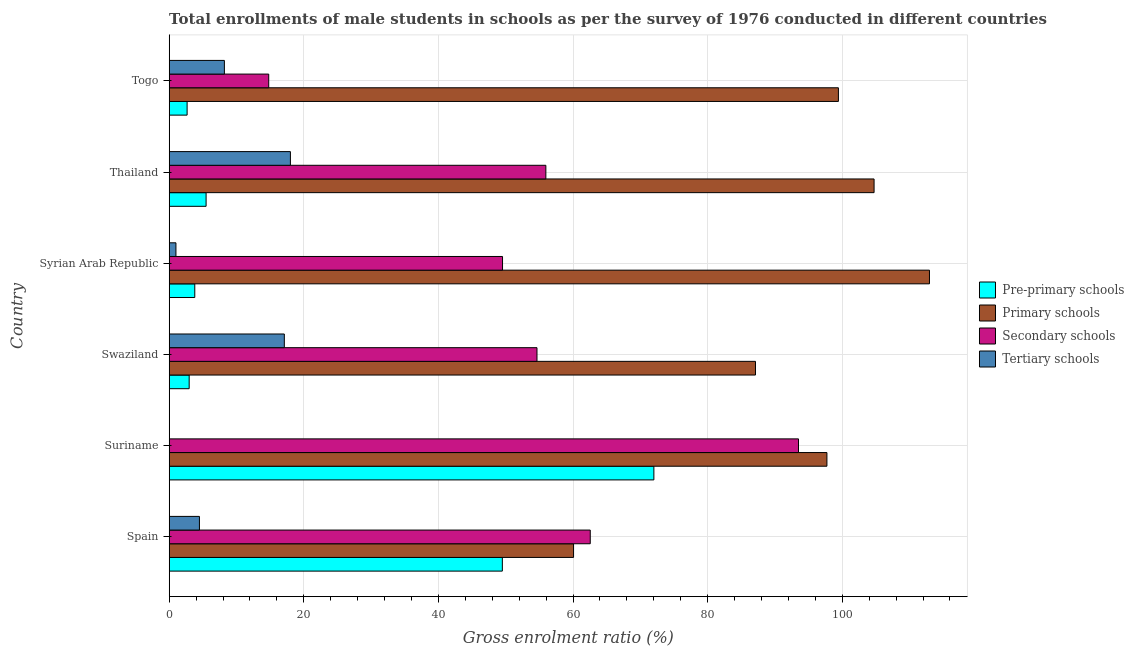How many different coloured bars are there?
Offer a very short reply. 4. How many groups of bars are there?
Your response must be concise. 6. Are the number of bars per tick equal to the number of legend labels?
Provide a succinct answer. Yes. How many bars are there on the 6th tick from the top?
Keep it short and to the point. 4. What is the label of the 1st group of bars from the top?
Keep it short and to the point. Togo. What is the gross enrolment ratio(male) in secondary schools in Swaziland?
Offer a terse response. 54.64. Across all countries, what is the maximum gross enrolment ratio(male) in pre-primary schools?
Ensure brevity in your answer.  72.01. Across all countries, what is the minimum gross enrolment ratio(male) in secondary schools?
Offer a terse response. 14.79. In which country was the gross enrolment ratio(male) in tertiary schools maximum?
Provide a succinct answer. Thailand. In which country was the gross enrolment ratio(male) in pre-primary schools minimum?
Give a very brief answer. Togo. What is the total gross enrolment ratio(male) in pre-primary schools in the graph?
Provide a succinct answer. 136.42. What is the difference between the gross enrolment ratio(male) in pre-primary schools in Suriname and that in Thailand?
Your response must be concise. 66.53. What is the difference between the gross enrolment ratio(male) in pre-primary schools in Suriname and the gross enrolment ratio(male) in secondary schools in Thailand?
Ensure brevity in your answer.  16.05. What is the average gross enrolment ratio(male) in tertiary schools per country?
Keep it short and to the point. 8.14. What is the difference between the gross enrolment ratio(male) in pre-primary schools and gross enrolment ratio(male) in tertiary schools in Syrian Arab Republic?
Ensure brevity in your answer.  2.8. In how many countries, is the gross enrolment ratio(male) in secondary schools greater than 48 %?
Provide a short and direct response. 5. What is the ratio of the gross enrolment ratio(male) in pre-primary schools in Spain to that in Swaziland?
Your response must be concise. 16.69. Is the gross enrolment ratio(male) in tertiary schools in Swaziland less than that in Togo?
Your answer should be very brief. No. What is the difference between the highest and the second highest gross enrolment ratio(male) in pre-primary schools?
Your response must be concise. 22.51. What is the difference between the highest and the lowest gross enrolment ratio(male) in pre-primary schools?
Your answer should be very brief. 69.35. Is the sum of the gross enrolment ratio(male) in tertiary schools in Suriname and Syrian Arab Republic greater than the maximum gross enrolment ratio(male) in secondary schools across all countries?
Make the answer very short. No. Is it the case that in every country, the sum of the gross enrolment ratio(male) in pre-primary schools and gross enrolment ratio(male) in primary schools is greater than the sum of gross enrolment ratio(male) in tertiary schools and gross enrolment ratio(male) in secondary schools?
Your answer should be very brief. Yes. What does the 3rd bar from the top in Swaziland represents?
Your answer should be very brief. Primary schools. What does the 4th bar from the bottom in Togo represents?
Make the answer very short. Tertiary schools. Is it the case that in every country, the sum of the gross enrolment ratio(male) in pre-primary schools and gross enrolment ratio(male) in primary schools is greater than the gross enrolment ratio(male) in secondary schools?
Make the answer very short. Yes. How many countries are there in the graph?
Provide a succinct answer. 6. What is the difference between two consecutive major ticks on the X-axis?
Give a very brief answer. 20. Where does the legend appear in the graph?
Your answer should be compact. Center right. How many legend labels are there?
Offer a very short reply. 4. How are the legend labels stacked?
Offer a very short reply. Vertical. What is the title of the graph?
Ensure brevity in your answer.  Total enrollments of male students in schools as per the survey of 1976 conducted in different countries. Does "Other greenhouse gases" appear as one of the legend labels in the graph?
Keep it short and to the point. No. What is the Gross enrolment ratio (%) of Pre-primary schools in Spain?
Offer a very short reply. 49.5. What is the Gross enrolment ratio (%) in Primary schools in Spain?
Keep it short and to the point. 60.08. What is the Gross enrolment ratio (%) in Secondary schools in Spain?
Your response must be concise. 62.56. What is the Gross enrolment ratio (%) in Tertiary schools in Spain?
Provide a succinct answer. 4.49. What is the Gross enrolment ratio (%) in Pre-primary schools in Suriname?
Offer a very short reply. 72.01. What is the Gross enrolment ratio (%) in Primary schools in Suriname?
Give a very brief answer. 97.72. What is the Gross enrolment ratio (%) of Secondary schools in Suriname?
Keep it short and to the point. 93.5. What is the Gross enrolment ratio (%) in Tertiary schools in Suriname?
Give a very brief answer. 0.03. What is the Gross enrolment ratio (%) of Pre-primary schools in Swaziland?
Your answer should be compact. 2.97. What is the Gross enrolment ratio (%) in Primary schools in Swaziland?
Ensure brevity in your answer.  87.11. What is the Gross enrolment ratio (%) of Secondary schools in Swaziland?
Ensure brevity in your answer.  54.64. What is the Gross enrolment ratio (%) in Tertiary schools in Swaziland?
Provide a short and direct response. 17.1. What is the Gross enrolment ratio (%) of Pre-primary schools in Syrian Arab Republic?
Your answer should be compact. 3.8. What is the Gross enrolment ratio (%) of Primary schools in Syrian Arab Republic?
Give a very brief answer. 112.96. What is the Gross enrolment ratio (%) of Secondary schools in Syrian Arab Republic?
Make the answer very short. 49.53. What is the Gross enrolment ratio (%) of Tertiary schools in Syrian Arab Republic?
Offer a very short reply. 1. What is the Gross enrolment ratio (%) of Pre-primary schools in Thailand?
Ensure brevity in your answer.  5.48. What is the Gross enrolment ratio (%) of Primary schools in Thailand?
Ensure brevity in your answer.  104.73. What is the Gross enrolment ratio (%) of Secondary schools in Thailand?
Offer a terse response. 55.96. What is the Gross enrolment ratio (%) in Tertiary schools in Thailand?
Offer a terse response. 18.01. What is the Gross enrolment ratio (%) of Pre-primary schools in Togo?
Make the answer very short. 2.66. What is the Gross enrolment ratio (%) in Primary schools in Togo?
Provide a short and direct response. 99.43. What is the Gross enrolment ratio (%) of Secondary schools in Togo?
Provide a short and direct response. 14.79. What is the Gross enrolment ratio (%) of Tertiary schools in Togo?
Your response must be concise. 8.2. Across all countries, what is the maximum Gross enrolment ratio (%) in Pre-primary schools?
Make the answer very short. 72.01. Across all countries, what is the maximum Gross enrolment ratio (%) of Primary schools?
Ensure brevity in your answer.  112.96. Across all countries, what is the maximum Gross enrolment ratio (%) in Secondary schools?
Provide a succinct answer. 93.5. Across all countries, what is the maximum Gross enrolment ratio (%) in Tertiary schools?
Your answer should be compact. 18.01. Across all countries, what is the minimum Gross enrolment ratio (%) of Pre-primary schools?
Keep it short and to the point. 2.66. Across all countries, what is the minimum Gross enrolment ratio (%) of Primary schools?
Offer a terse response. 60.08. Across all countries, what is the minimum Gross enrolment ratio (%) in Secondary schools?
Keep it short and to the point. 14.79. Across all countries, what is the minimum Gross enrolment ratio (%) of Tertiary schools?
Your answer should be very brief. 0.03. What is the total Gross enrolment ratio (%) in Pre-primary schools in the graph?
Offer a very short reply. 136.42. What is the total Gross enrolment ratio (%) in Primary schools in the graph?
Offer a very short reply. 562.03. What is the total Gross enrolment ratio (%) of Secondary schools in the graph?
Give a very brief answer. 330.98. What is the total Gross enrolment ratio (%) in Tertiary schools in the graph?
Keep it short and to the point. 48.83. What is the difference between the Gross enrolment ratio (%) in Pre-primary schools in Spain and that in Suriname?
Your response must be concise. -22.51. What is the difference between the Gross enrolment ratio (%) of Primary schools in Spain and that in Suriname?
Offer a terse response. -37.64. What is the difference between the Gross enrolment ratio (%) of Secondary schools in Spain and that in Suriname?
Provide a short and direct response. -30.94. What is the difference between the Gross enrolment ratio (%) of Tertiary schools in Spain and that in Suriname?
Ensure brevity in your answer.  4.47. What is the difference between the Gross enrolment ratio (%) of Pre-primary schools in Spain and that in Swaziland?
Your response must be concise. 46.53. What is the difference between the Gross enrolment ratio (%) in Primary schools in Spain and that in Swaziland?
Offer a terse response. -27.03. What is the difference between the Gross enrolment ratio (%) of Secondary schools in Spain and that in Swaziland?
Keep it short and to the point. 7.92. What is the difference between the Gross enrolment ratio (%) in Tertiary schools in Spain and that in Swaziland?
Provide a succinct answer. -12.61. What is the difference between the Gross enrolment ratio (%) of Pre-primary schools in Spain and that in Syrian Arab Republic?
Keep it short and to the point. 45.7. What is the difference between the Gross enrolment ratio (%) of Primary schools in Spain and that in Syrian Arab Republic?
Provide a short and direct response. -52.88. What is the difference between the Gross enrolment ratio (%) in Secondary schools in Spain and that in Syrian Arab Republic?
Keep it short and to the point. 13.03. What is the difference between the Gross enrolment ratio (%) in Tertiary schools in Spain and that in Syrian Arab Republic?
Make the answer very short. 3.49. What is the difference between the Gross enrolment ratio (%) of Pre-primary schools in Spain and that in Thailand?
Your answer should be compact. 44.02. What is the difference between the Gross enrolment ratio (%) of Primary schools in Spain and that in Thailand?
Provide a short and direct response. -44.65. What is the difference between the Gross enrolment ratio (%) in Secondary schools in Spain and that in Thailand?
Ensure brevity in your answer.  6.6. What is the difference between the Gross enrolment ratio (%) in Tertiary schools in Spain and that in Thailand?
Give a very brief answer. -13.52. What is the difference between the Gross enrolment ratio (%) in Pre-primary schools in Spain and that in Togo?
Your answer should be very brief. 46.84. What is the difference between the Gross enrolment ratio (%) in Primary schools in Spain and that in Togo?
Make the answer very short. -39.35. What is the difference between the Gross enrolment ratio (%) of Secondary schools in Spain and that in Togo?
Provide a succinct answer. 47.77. What is the difference between the Gross enrolment ratio (%) in Tertiary schools in Spain and that in Togo?
Your response must be concise. -3.71. What is the difference between the Gross enrolment ratio (%) of Pre-primary schools in Suriname and that in Swaziland?
Offer a very short reply. 69.04. What is the difference between the Gross enrolment ratio (%) in Primary schools in Suriname and that in Swaziland?
Offer a very short reply. 10.62. What is the difference between the Gross enrolment ratio (%) in Secondary schools in Suriname and that in Swaziland?
Make the answer very short. 38.86. What is the difference between the Gross enrolment ratio (%) of Tertiary schools in Suriname and that in Swaziland?
Your answer should be very brief. -17.08. What is the difference between the Gross enrolment ratio (%) in Pre-primary schools in Suriname and that in Syrian Arab Republic?
Your response must be concise. 68.21. What is the difference between the Gross enrolment ratio (%) of Primary schools in Suriname and that in Syrian Arab Republic?
Give a very brief answer. -15.23. What is the difference between the Gross enrolment ratio (%) of Secondary schools in Suriname and that in Syrian Arab Republic?
Offer a very short reply. 43.97. What is the difference between the Gross enrolment ratio (%) in Tertiary schools in Suriname and that in Syrian Arab Republic?
Ensure brevity in your answer.  -0.97. What is the difference between the Gross enrolment ratio (%) of Pre-primary schools in Suriname and that in Thailand?
Offer a terse response. 66.53. What is the difference between the Gross enrolment ratio (%) in Primary schools in Suriname and that in Thailand?
Offer a very short reply. -7.01. What is the difference between the Gross enrolment ratio (%) of Secondary schools in Suriname and that in Thailand?
Give a very brief answer. 37.54. What is the difference between the Gross enrolment ratio (%) of Tertiary schools in Suriname and that in Thailand?
Ensure brevity in your answer.  -17.98. What is the difference between the Gross enrolment ratio (%) in Pre-primary schools in Suriname and that in Togo?
Offer a very short reply. 69.35. What is the difference between the Gross enrolment ratio (%) of Primary schools in Suriname and that in Togo?
Your answer should be compact. -1.71. What is the difference between the Gross enrolment ratio (%) in Secondary schools in Suriname and that in Togo?
Your answer should be very brief. 78.71. What is the difference between the Gross enrolment ratio (%) of Tertiary schools in Suriname and that in Togo?
Keep it short and to the point. -8.17. What is the difference between the Gross enrolment ratio (%) of Pre-primary schools in Swaziland and that in Syrian Arab Republic?
Keep it short and to the point. -0.83. What is the difference between the Gross enrolment ratio (%) of Primary schools in Swaziland and that in Syrian Arab Republic?
Your response must be concise. -25.85. What is the difference between the Gross enrolment ratio (%) in Secondary schools in Swaziland and that in Syrian Arab Republic?
Offer a terse response. 5.12. What is the difference between the Gross enrolment ratio (%) in Tertiary schools in Swaziland and that in Syrian Arab Republic?
Offer a terse response. 16.1. What is the difference between the Gross enrolment ratio (%) of Pre-primary schools in Swaziland and that in Thailand?
Offer a terse response. -2.51. What is the difference between the Gross enrolment ratio (%) in Primary schools in Swaziland and that in Thailand?
Keep it short and to the point. -17.62. What is the difference between the Gross enrolment ratio (%) of Secondary schools in Swaziland and that in Thailand?
Offer a terse response. -1.32. What is the difference between the Gross enrolment ratio (%) of Tertiary schools in Swaziland and that in Thailand?
Keep it short and to the point. -0.9. What is the difference between the Gross enrolment ratio (%) in Pre-primary schools in Swaziland and that in Togo?
Provide a succinct answer. 0.31. What is the difference between the Gross enrolment ratio (%) in Primary schools in Swaziland and that in Togo?
Keep it short and to the point. -12.32. What is the difference between the Gross enrolment ratio (%) in Secondary schools in Swaziland and that in Togo?
Make the answer very short. 39.86. What is the difference between the Gross enrolment ratio (%) in Tertiary schools in Swaziland and that in Togo?
Ensure brevity in your answer.  8.91. What is the difference between the Gross enrolment ratio (%) of Pre-primary schools in Syrian Arab Republic and that in Thailand?
Give a very brief answer. -1.68. What is the difference between the Gross enrolment ratio (%) of Primary schools in Syrian Arab Republic and that in Thailand?
Provide a short and direct response. 8.23. What is the difference between the Gross enrolment ratio (%) of Secondary schools in Syrian Arab Republic and that in Thailand?
Provide a succinct answer. -6.44. What is the difference between the Gross enrolment ratio (%) in Tertiary schools in Syrian Arab Republic and that in Thailand?
Provide a short and direct response. -17.01. What is the difference between the Gross enrolment ratio (%) in Pre-primary schools in Syrian Arab Republic and that in Togo?
Offer a terse response. 1.14. What is the difference between the Gross enrolment ratio (%) in Primary schools in Syrian Arab Republic and that in Togo?
Your response must be concise. 13.53. What is the difference between the Gross enrolment ratio (%) in Secondary schools in Syrian Arab Republic and that in Togo?
Your answer should be very brief. 34.74. What is the difference between the Gross enrolment ratio (%) of Tertiary schools in Syrian Arab Republic and that in Togo?
Your answer should be very brief. -7.2. What is the difference between the Gross enrolment ratio (%) of Pre-primary schools in Thailand and that in Togo?
Give a very brief answer. 2.82. What is the difference between the Gross enrolment ratio (%) in Primary schools in Thailand and that in Togo?
Ensure brevity in your answer.  5.3. What is the difference between the Gross enrolment ratio (%) in Secondary schools in Thailand and that in Togo?
Your answer should be very brief. 41.18. What is the difference between the Gross enrolment ratio (%) of Tertiary schools in Thailand and that in Togo?
Provide a succinct answer. 9.81. What is the difference between the Gross enrolment ratio (%) of Pre-primary schools in Spain and the Gross enrolment ratio (%) of Primary schools in Suriname?
Ensure brevity in your answer.  -48.23. What is the difference between the Gross enrolment ratio (%) in Pre-primary schools in Spain and the Gross enrolment ratio (%) in Secondary schools in Suriname?
Your answer should be compact. -44. What is the difference between the Gross enrolment ratio (%) of Pre-primary schools in Spain and the Gross enrolment ratio (%) of Tertiary schools in Suriname?
Offer a very short reply. 49.47. What is the difference between the Gross enrolment ratio (%) of Primary schools in Spain and the Gross enrolment ratio (%) of Secondary schools in Suriname?
Provide a short and direct response. -33.42. What is the difference between the Gross enrolment ratio (%) of Primary schools in Spain and the Gross enrolment ratio (%) of Tertiary schools in Suriname?
Your answer should be compact. 60.05. What is the difference between the Gross enrolment ratio (%) of Secondary schools in Spain and the Gross enrolment ratio (%) of Tertiary schools in Suriname?
Keep it short and to the point. 62.53. What is the difference between the Gross enrolment ratio (%) in Pre-primary schools in Spain and the Gross enrolment ratio (%) in Primary schools in Swaziland?
Give a very brief answer. -37.61. What is the difference between the Gross enrolment ratio (%) of Pre-primary schools in Spain and the Gross enrolment ratio (%) of Secondary schools in Swaziland?
Your answer should be very brief. -5.15. What is the difference between the Gross enrolment ratio (%) of Pre-primary schools in Spain and the Gross enrolment ratio (%) of Tertiary schools in Swaziland?
Your response must be concise. 32.39. What is the difference between the Gross enrolment ratio (%) in Primary schools in Spain and the Gross enrolment ratio (%) in Secondary schools in Swaziland?
Offer a terse response. 5.44. What is the difference between the Gross enrolment ratio (%) of Primary schools in Spain and the Gross enrolment ratio (%) of Tertiary schools in Swaziland?
Your response must be concise. 42.97. What is the difference between the Gross enrolment ratio (%) in Secondary schools in Spain and the Gross enrolment ratio (%) in Tertiary schools in Swaziland?
Make the answer very short. 45.45. What is the difference between the Gross enrolment ratio (%) in Pre-primary schools in Spain and the Gross enrolment ratio (%) in Primary schools in Syrian Arab Republic?
Keep it short and to the point. -63.46. What is the difference between the Gross enrolment ratio (%) in Pre-primary schools in Spain and the Gross enrolment ratio (%) in Secondary schools in Syrian Arab Republic?
Make the answer very short. -0.03. What is the difference between the Gross enrolment ratio (%) in Pre-primary schools in Spain and the Gross enrolment ratio (%) in Tertiary schools in Syrian Arab Republic?
Keep it short and to the point. 48.5. What is the difference between the Gross enrolment ratio (%) in Primary schools in Spain and the Gross enrolment ratio (%) in Secondary schools in Syrian Arab Republic?
Your response must be concise. 10.55. What is the difference between the Gross enrolment ratio (%) in Primary schools in Spain and the Gross enrolment ratio (%) in Tertiary schools in Syrian Arab Republic?
Give a very brief answer. 59.08. What is the difference between the Gross enrolment ratio (%) of Secondary schools in Spain and the Gross enrolment ratio (%) of Tertiary schools in Syrian Arab Republic?
Your answer should be compact. 61.56. What is the difference between the Gross enrolment ratio (%) in Pre-primary schools in Spain and the Gross enrolment ratio (%) in Primary schools in Thailand?
Your response must be concise. -55.23. What is the difference between the Gross enrolment ratio (%) in Pre-primary schools in Spain and the Gross enrolment ratio (%) in Secondary schools in Thailand?
Make the answer very short. -6.46. What is the difference between the Gross enrolment ratio (%) of Pre-primary schools in Spain and the Gross enrolment ratio (%) of Tertiary schools in Thailand?
Your response must be concise. 31.49. What is the difference between the Gross enrolment ratio (%) of Primary schools in Spain and the Gross enrolment ratio (%) of Secondary schools in Thailand?
Keep it short and to the point. 4.12. What is the difference between the Gross enrolment ratio (%) of Primary schools in Spain and the Gross enrolment ratio (%) of Tertiary schools in Thailand?
Keep it short and to the point. 42.07. What is the difference between the Gross enrolment ratio (%) of Secondary schools in Spain and the Gross enrolment ratio (%) of Tertiary schools in Thailand?
Give a very brief answer. 44.55. What is the difference between the Gross enrolment ratio (%) of Pre-primary schools in Spain and the Gross enrolment ratio (%) of Primary schools in Togo?
Offer a very short reply. -49.93. What is the difference between the Gross enrolment ratio (%) in Pre-primary schools in Spain and the Gross enrolment ratio (%) in Secondary schools in Togo?
Provide a succinct answer. 34.71. What is the difference between the Gross enrolment ratio (%) in Pre-primary schools in Spain and the Gross enrolment ratio (%) in Tertiary schools in Togo?
Keep it short and to the point. 41.3. What is the difference between the Gross enrolment ratio (%) in Primary schools in Spain and the Gross enrolment ratio (%) in Secondary schools in Togo?
Offer a very short reply. 45.29. What is the difference between the Gross enrolment ratio (%) in Primary schools in Spain and the Gross enrolment ratio (%) in Tertiary schools in Togo?
Give a very brief answer. 51.88. What is the difference between the Gross enrolment ratio (%) of Secondary schools in Spain and the Gross enrolment ratio (%) of Tertiary schools in Togo?
Your response must be concise. 54.36. What is the difference between the Gross enrolment ratio (%) in Pre-primary schools in Suriname and the Gross enrolment ratio (%) in Primary schools in Swaziland?
Provide a short and direct response. -15.1. What is the difference between the Gross enrolment ratio (%) in Pre-primary schools in Suriname and the Gross enrolment ratio (%) in Secondary schools in Swaziland?
Keep it short and to the point. 17.37. What is the difference between the Gross enrolment ratio (%) of Pre-primary schools in Suriname and the Gross enrolment ratio (%) of Tertiary schools in Swaziland?
Give a very brief answer. 54.91. What is the difference between the Gross enrolment ratio (%) in Primary schools in Suriname and the Gross enrolment ratio (%) in Secondary schools in Swaziland?
Provide a succinct answer. 43.08. What is the difference between the Gross enrolment ratio (%) of Primary schools in Suriname and the Gross enrolment ratio (%) of Tertiary schools in Swaziland?
Keep it short and to the point. 80.62. What is the difference between the Gross enrolment ratio (%) of Secondary schools in Suriname and the Gross enrolment ratio (%) of Tertiary schools in Swaziland?
Offer a terse response. 76.39. What is the difference between the Gross enrolment ratio (%) of Pre-primary schools in Suriname and the Gross enrolment ratio (%) of Primary schools in Syrian Arab Republic?
Provide a short and direct response. -40.95. What is the difference between the Gross enrolment ratio (%) of Pre-primary schools in Suriname and the Gross enrolment ratio (%) of Secondary schools in Syrian Arab Republic?
Offer a very short reply. 22.48. What is the difference between the Gross enrolment ratio (%) of Pre-primary schools in Suriname and the Gross enrolment ratio (%) of Tertiary schools in Syrian Arab Republic?
Provide a succinct answer. 71.01. What is the difference between the Gross enrolment ratio (%) of Primary schools in Suriname and the Gross enrolment ratio (%) of Secondary schools in Syrian Arab Republic?
Provide a succinct answer. 48.2. What is the difference between the Gross enrolment ratio (%) of Primary schools in Suriname and the Gross enrolment ratio (%) of Tertiary schools in Syrian Arab Republic?
Provide a succinct answer. 96.72. What is the difference between the Gross enrolment ratio (%) of Secondary schools in Suriname and the Gross enrolment ratio (%) of Tertiary schools in Syrian Arab Republic?
Offer a very short reply. 92.5. What is the difference between the Gross enrolment ratio (%) in Pre-primary schools in Suriname and the Gross enrolment ratio (%) in Primary schools in Thailand?
Offer a very short reply. -32.72. What is the difference between the Gross enrolment ratio (%) of Pre-primary schools in Suriname and the Gross enrolment ratio (%) of Secondary schools in Thailand?
Ensure brevity in your answer.  16.05. What is the difference between the Gross enrolment ratio (%) in Pre-primary schools in Suriname and the Gross enrolment ratio (%) in Tertiary schools in Thailand?
Offer a very short reply. 54. What is the difference between the Gross enrolment ratio (%) of Primary schools in Suriname and the Gross enrolment ratio (%) of Secondary schools in Thailand?
Provide a succinct answer. 41.76. What is the difference between the Gross enrolment ratio (%) of Primary schools in Suriname and the Gross enrolment ratio (%) of Tertiary schools in Thailand?
Make the answer very short. 79.72. What is the difference between the Gross enrolment ratio (%) in Secondary schools in Suriname and the Gross enrolment ratio (%) in Tertiary schools in Thailand?
Offer a very short reply. 75.49. What is the difference between the Gross enrolment ratio (%) of Pre-primary schools in Suriname and the Gross enrolment ratio (%) of Primary schools in Togo?
Give a very brief answer. -27.42. What is the difference between the Gross enrolment ratio (%) in Pre-primary schools in Suriname and the Gross enrolment ratio (%) in Secondary schools in Togo?
Your response must be concise. 57.23. What is the difference between the Gross enrolment ratio (%) in Pre-primary schools in Suriname and the Gross enrolment ratio (%) in Tertiary schools in Togo?
Make the answer very short. 63.81. What is the difference between the Gross enrolment ratio (%) of Primary schools in Suriname and the Gross enrolment ratio (%) of Secondary schools in Togo?
Your answer should be very brief. 82.94. What is the difference between the Gross enrolment ratio (%) of Primary schools in Suriname and the Gross enrolment ratio (%) of Tertiary schools in Togo?
Keep it short and to the point. 89.52. What is the difference between the Gross enrolment ratio (%) of Secondary schools in Suriname and the Gross enrolment ratio (%) of Tertiary schools in Togo?
Provide a succinct answer. 85.3. What is the difference between the Gross enrolment ratio (%) of Pre-primary schools in Swaziland and the Gross enrolment ratio (%) of Primary schools in Syrian Arab Republic?
Provide a short and direct response. -109.99. What is the difference between the Gross enrolment ratio (%) in Pre-primary schools in Swaziland and the Gross enrolment ratio (%) in Secondary schools in Syrian Arab Republic?
Give a very brief answer. -46.56. What is the difference between the Gross enrolment ratio (%) of Pre-primary schools in Swaziland and the Gross enrolment ratio (%) of Tertiary schools in Syrian Arab Republic?
Your answer should be very brief. 1.97. What is the difference between the Gross enrolment ratio (%) in Primary schools in Swaziland and the Gross enrolment ratio (%) in Secondary schools in Syrian Arab Republic?
Your answer should be compact. 37.58. What is the difference between the Gross enrolment ratio (%) in Primary schools in Swaziland and the Gross enrolment ratio (%) in Tertiary schools in Syrian Arab Republic?
Provide a succinct answer. 86.11. What is the difference between the Gross enrolment ratio (%) of Secondary schools in Swaziland and the Gross enrolment ratio (%) of Tertiary schools in Syrian Arab Republic?
Your response must be concise. 53.64. What is the difference between the Gross enrolment ratio (%) in Pre-primary schools in Swaziland and the Gross enrolment ratio (%) in Primary schools in Thailand?
Provide a succinct answer. -101.76. What is the difference between the Gross enrolment ratio (%) of Pre-primary schools in Swaziland and the Gross enrolment ratio (%) of Secondary schools in Thailand?
Your answer should be compact. -53. What is the difference between the Gross enrolment ratio (%) of Pre-primary schools in Swaziland and the Gross enrolment ratio (%) of Tertiary schools in Thailand?
Your answer should be compact. -15.04. What is the difference between the Gross enrolment ratio (%) in Primary schools in Swaziland and the Gross enrolment ratio (%) in Secondary schools in Thailand?
Provide a short and direct response. 31.15. What is the difference between the Gross enrolment ratio (%) in Primary schools in Swaziland and the Gross enrolment ratio (%) in Tertiary schools in Thailand?
Give a very brief answer. 69.1. What is the difference between the Gross enrolment ratio (%) of Secondary schools in Swaziland and the Gross enrolment ratio (%) of Tertiary schools in Thailand?
Offer a terse response. 36.64. What is the difference between the Gross enrolment ratio (%) in Pre-primary schools in Swaziland and the Gross enrolment ratio (%) in Primary schools in Togo?
Your response must be concise. -96.46. What is the difference between the Gross enrolment ratio (%) of Pre-primary schools in Swaziland and the Gross enrolment ratio (%) of Secondary schools in Togo?
Make the answer very short. -11.82. What is the difference between the Gross enrolment ratio (%) of Pre-primary schools in Swaziland and the Gross enrolment ratio (%) of Tertiary schools in Togo?
Your response must be concise. -5.23. What is the difference between the Gross enrolment ratio (%) in Primary schools in Swaziland and the Gross enrolment ratio (%) in Secondary schools in Togo?
Give a very brief answer. 72.32. What is the difference between the Gross enrolment ratio (%) of Primary schools in Swaziland and the Gross enrolment ratio (%) of Tertiary schools in Togo?
Provide a succinct answer. 78.91. What is the difference between the Gross enrolment ratio (%) of Secondary schools in Swaziland and the Gross enrolment ratio (%) of Tertiary schools in Togo?
Your answer should be compact. 46.44. What is the difference between the Gross enrolment ratio (%) in Pre-primary schools in Syrian Arab Republic and the Gross enrolment ratio (%) in Primary schools in Thailand?
Your response must be concise. -100.93. What is the difference between the Gross enrolment ratio (%) in Pre-primary schools in Syrian Arab Republic and the Gross enrolment ratio (%) in Secondary schools in Thailand?
Your response must be concise. -52.16. What is the difference between the Gross enrolment ratio (%) in Pre-primary schools in Syrian Arab Republic and the Gross enrolment ratio (%) in Tertiary schools in Thailand?
Ensure brevity in your answer.  -14.21. What is the difference between the Gross enrolment ratio (%) in Primary schools in Syrian Arab Republic and the Gross enrolment ratio (%) in Secondary schools in Thailand?
Your response must be concise. 57. What is the difference between the Gross enrolment ratio (%) in Primary schools in Syrian Arab Republic and the Gross enrolment ratio (%) in Tertiary schools in Thailand?
Ensure brevity in your answer.  94.95. What is the difference between the Gross enrolment ratio (%) in Secondary schools in Syrian Arab Republic and the Gross enrolment ratio (%) in Tertiary schools in Thailand?
Give a very brief answer. 31.52. What is the difference between the Gross enrolment ratio (%) in Pre-primary schools in Syrian Arab Republic and the Gross enrolment ratio (%) in Primary schools in Togo?
Offer a very short reply. -95.63. What is the difference between the Gross enrolment ratio (%) of Pre-primary schools in Syrian Arab Republic and the Gross enrolment ratio (%) of Secondary schools in Togo?
Ensure brevity in your answer.  -10.99. What is the difference between the Gross enrolment ratio (%) in Pre-primary schools in Syrian Arab Republic and the Gross enrolment ratio (%) in Tertiary schools in Togo?
Provide a short and direct response. -4.4. What is the difference between the Gross enrolment ratio (%) of Primary schools in Syrian Arab Republic and the Gross enrolment ratio (%) of Secondary schools in Togo?
Make the answer very short. 98.17. What is the difference between the Gross enrolment ratio (%) in Primary schools in Syrian Arab Republic and the Gross enrolment ratio (%) in Tertiary schools in Togo?
Your answer should be compact. 104.76. What is the difference between the Gross enrolment ratio (%) in Secondary schools in Syrian Arab Republic and the Gross enrolment ratio (%) in Tertiary schools in Togo?
Offer a terse response. 41.33. What is the difference between the Gross enrolment ratio (%) of Pre-primary schools in Thailand and the Gross enrolment ratio (%) of Primary schools in Togo?
Your response must be concise. -93.95. What is the difference between the Gross enrolment ratio (%) in Pre-primary schools in Thailand and the Gross enrolment ratio (%) in Secondary schools in Togo?
Your answer should be compact. -9.3. What is the difference between the Gross enrolment ratio (%) in Pre-primary schools in Thailand and the Gross enrolment ratio (%) in Tertiary schools in Togo?
Your answer should be compact. -2.72. What is the difference between the Gross enrolment ratio (%) of Primary schools in Thailand and the Gross enrolment ratio (%) of Secondary schools in Togo?
Make the answer very short. 89.94. What is the difference between the Gross enrolment ratio (%) in Primary schools in Thailand and the Gross enrolment ratio (%) in Tertiary schools in Togo?
Your answer should be compact. 96.53. What is the difference between the Gross enrolment ratio (%) in Secondary schools in Thailand and the Gross enrolment ratio (%) in Tertiary schools in Togo?
Make the answer very short. 47.76. What is the average Gross enrolment ratio (%) in Pre-primary schools per country?
Offer a terse response. 22.74. What is the average Gross enrolment ratio (%) in Primary schools per country?
Make the answer very short. 93.67. What is the average Gross enrolment ratio (%) in Secondary schools per country?
Make the answer very short. 55.16. What is the average Gross enrolment ratio (%) in Tertiary schools per country?
Your answer should be compact. 8.14. What is the difference between the Gross enrolment ratio (%) of Pre-primary schools and Gross enrolment ratio (%) of Primary schools in Spain?
Provide a short and direct response. -10.58. What is the difference between the Gross enrolment ratio (%) of Pre-primary schools and Gross enrolment ratio (%) of Secondary schools in Spain?
Ensure brevity in your answer.  -13.06. What is the difference between the Gross enrolment ratio (%) in Pre-primary schools and Gross enrolment ratio (%) in Tertiary schools in Spain?
Your answer should be very brief. 45.01. What is the difference between the Gross enrolment ratio (%) in Primary schools and Gross enrolment ratio (%) in Secondary schools in Spain?
Ensure brevity in your answer.  -2.48. What is the difference between the Gross enrolment ratio (%) in Primary schools and Gross enrolment ratio (%) in Tertiary schools in Spain?
Offer a terse response. 55.59. What is the difference between the Gross enrolment ratio (%) in Secondary schools and Gross enrolment ratio (%) in Tertiary schools in Spain?
Provide a short and direct response. 58.07. What is the difference between the Gross enrolment ratio (%) of Pre-primary schools and Gross enrolment ratio (%) of Primary schools in Suriname?
Keep it short and to the point. -25.71. What is the difference between the Gross enrolment ratio (%) of Pre-primary schools and Gross enrolment ratio (%) of Secondary schools in Suriname?
Make the answer very short. -21.49. What is the difference between the Gross enrolment ratio (%) in Pre-primary schools and Gross enrolment ratio (%) in Tertiary schools in Suriname?
Give a very brief answer. 71.98. What is the difference between the Gross enrolment ratio (%) of Primary schools and Gross enrolment ratio (%) of Secondary schools in Suriname?
Make the answer very short. 4.22. What is the difference between the Gross enrolment ratio (%) in Primary schools and Gross enrolment ratio (%) in Tertiary schools in Suriname?
Make the answer very short. 97.7. What is the difference between the Gross enrolment ratio (%) of Secondary schools and Gross enrolment ratio (%) of Tertiary schools in Suriname?
Your answer should be compact. 93.47. What is the difference between the Gross enrolment ratio (%) of Pre-primary schools and Gross enrolment ratio (%) of Primary schools in Swaziland?
Give a very brief answer. -84.14. What is the difference between the Gross enrolment ratio (%) of Pre-primary schools and Gross enrolment ratio (%) of Secondary schools in Swaziland?
Keep it short and to the point. -51.68. What is the difference between the Gross enrolment ratio (%) of Pre-primary schools and Gross enrolment ratio (%) of Tertiary schools in Swaziland?
Your answer should be compact. -14.14. What is the difference between the Gross enrolment ratio (%) in Primary schools and Gross enrolment ratio (%) in Secondary schools in Swaziland?
Make the answer very short. 32.46. What is the difference between the Gross enrolment ratio (%) of Primary schools and Gross enrolment ratio (%) of Tertiary schools in Swaziland?
Keep it short and to the point. 70. What is the difference between the Gross enrolment ratio (%) of Secondary schools and Gross enrolment ratio (%) of Tertiary schools in Swaziland?
Offer a very short reply. 37.54. What is the difference between the Gross enrolment ratio (%) of Pre-primary schools and Gross enrolment ratio (%) of Primary schools in Syrian Arab Republic?
Your answer should be very brief. -109.16. What is the difference between the Gross enrolment ratio (%) of Pre-primary schools and Gross enrolment ratio (%) of Secondary schools in Syrian Arab Republic?
Your answer should be compact. -45.73. What is the difference between the Gross enrolment ratio (%) of Pre-primary schools and Gross enrolment ratio (%) of Tertiary schools in Syrian Arab Republic?
Offer a terse response. 2.8. What is the difference between the Gross enrolment ratio (%) of Primary schools and Gross enrolment ratio (%) of Secondary schools in Syrian Arab Republic?
Your answer should be very brief. 63.43. What is the difference between the Gross enrolment ratio (%) of Primary schools and Gross enrolment ratio (%) of Tertiary schools in Syrian Arab Republic?
Provide a short and direct response. 111.96. What is the difference between the Gross enrolment ratio (%) of Secondary schools and Gross enrolment ratio (%) of Tertiary schools in Syrian Arab Republic?
Provide a short and direct response. 48.53. What is the difference between the Gross enrolment ratio (%) of Pre-primary schools and Gross enrolment ratio (%) of Primary schools in Thailand?
Keep it short and to the point. -99.25. What is the difference between the Gross enrolment ratio (%) in Pre-primary schools and Gross enrolment ratio (%) in Secondary schools in Thailand?
Keep it short and to the point. -50.48. What is the difference between the Gross enrolment ratio (%) of Pre-primary schools and Gross enrolment ratio (%) of Tertiary schools in Thailand?
Your answer should be compact. -12.53. What is the difference between the Gross enrolment ratio (%) in Primary schools and Gross enrolment ratio (%) in Secondary schools in Thailand?
Offer a very short reply. 48.77. What is the difference between the Gross enrolment ratio (%) in Primary schools and Gross enrolment ratio (%) in Tertiary schools in Thailand?
Give a very brief answer. 86.72. What is the difference between the Gross enrolment ratio (%) in Secondary schools and Gross enrolment ratio (%) in Tertiary schools in Thailand?
Ensure brevity in your answer.  37.95. What is the difference between the Gross enrolment ratio (%) of Pre-primary schools and Gross enrolment ratio (%) of Primary schools in Togo?
Your response must be concise. -96.77. What is the difference between the Gross enrolment ratio (%) in Pre-primary schools and Gross enrolment ratio (%) in Secondary schools in Togo?
Make the answer very short. -12.13. What is the difference between the Gross enrolment ratio (%) of Pre-primary schools and Gross enrolment ratio (%) of Tertiary schools in Togo?
Offer a terse response. -5.54. What is the difference between the Gross enrolment ratio (%) of Primary schools and Gross enrolment ratio (%) of Secondary schools in Togo?
Keep it short and to the point. 84.64. What is the difference between the Gross enrolment ratio (%) in Primary schools and Gross enrolment ratio (%) in Tertiary schools in Togo?
Your answer should be very brief. 91.23. What is the difference between the Gross enrolment ratio (%) of Secondary schools and Gross enrolment ratio (%) of Tertiary schools in Togo?
Ensure brevity in your answer.  6.59. What is the ratio of the Gross enrolment ratio (%) of Pre-primary schools in Spain to that in Suriname?
Make the answer very short. 0.69. What is the ratio of the Gross enrolment ratio (%) of Primary schools in Spain to that in Suriname?
Offer a very short reply. 0.61. What is the ratio of the Gross enrolment ratio (%) in Secondary schools in Spain to that in Suriname?
Ensure brevity in your answer.  0.67. What is the ratio of the Gross enrolment ratio (%) of Tertiary schools in Spain to that in Suriname?
Your response must be concise. 168.27. What is the ratio of the Gross enrolment ratio (%) in Pre-primary schools in Spain to that in Swaziland?
Offer a terse response. 16.69. What is the ratio of the Gross enrolment ratio (%) in Primary schools in Spain to that in Swaziland?
Ensure brevity in your answer.  0.69. What is the ratio of the Gross enrolment ratio (%) of Secondary schools in Spain to that in Swaziland?
Your answer should be compact. 1.14. What is the ratio of the Gross enrolment ratio (%) in Tertiary schools in Spain to that in Swaziland?
Ensure brevity in your answer.  0.26. What is the ratio of the Gross enrolment ratio (%) in Pre-primary schools in Spain to that in Syrian Arab Republic?
Your answer should be compact. 13.03. What is the ratio of the Gross enrolment ratio (%) of Primary schools in Spain to that in Syrian Arab Republic?
Your answer should be compact. 0.53. What is the ratio of the Gross enrolment ratio (%) in Secondary schools in Spain to that in Syrian Arab Republic?
Your response must be concise. 1.26. What is the ratio of the Gross enrolment ratio (%) of Tertiary schools in Spain to that in Syrian Arab Republic?
Provide a short and direct response. 4.49. What is the ratio of the Gross enrolment ratio (%) in Pre-primary schools in Spain to that in Thailand?
Provide a succinct answer. 9.03. What is the ratio of the Gross enrolment ratio (%) in Primary schools in Spain to that in Thailand?
Offer a very short reply. 0.57. What is the ratio of the Gross enrolment ratio (%) in Secondary schools in Spain to that in Thailand?
Your answer should be very brief. 1.12. What is the ratio of the Gross enrolment ratio (%) in Tertiary schools in Spain to that in Thailand?
Ensure brevity in your answer.  0.25. What is the ratio of the Gross enrolment ratio (%) in Pre-primary schools in Spain to that in Togo?
Ensure brevity in your answer.  18.61. What is the ratio of the Gross enrolment ratio (%) in Primary schools in Spain to that in Togo?
Ensure brevity in your answer.  0.6. What is the ratio of the Gross enrolment ratio (%) in Secondary schools in Spain to that in Togo?
Your response must be concise. 4.23. What is the ratio of the Gross enrolment ratio (%) of Tertiary schools in Spain to that in Togo?
Keep it short and to the point. 0.55. What is the ratio of the Gross enrolment ratio (%) in Pre-primary schools in Suriname to that in Swaziland?
Offer a terse response. 24.28. What is the ratio of the Gross enrolment ratio (%) in Primary schools in Suriname to that in Swaziland?
Offer a very short reply. 1.12. What is the ratio of the Gross enrolment ratio (%) in Secondary schools in Suriname to that in Swaziland?
Your answer should be very brief. 1.71. What is the ratio of the Gross enrolment ratio (%) of Tertiary schools in Suriname to that in Swaziland?
Give a very brief answer. 0. What is the ratio of the Gross enrolment ratio (%) of Pre-primary schools in Suriname to that in Syrian Arab Republic?
Keep it short and to the point. 18.96. What is the ratio of the Gross enrolment ratio (%) in Primary schools in Suriname to that in Syrian Arab Republic?
Your answer should be compact. 0.87. What is the ratio of the Gross enrolment ratio (%) of Secondary schools in Suriname to that in Syrian Arab Republic?
Ensure brevity in your answer.  1.89. What is the ratio of the Gross enrolment ratio (%) of Tertiary schools in Suriname to that in Syrian Arab Republic?
Give a very brief answer. 0.03. What is the ratio of the Gross enrolment ratio (%) of Pre-primary schools in Suriname to that in Thailand?
Give a very brief answer. 13.14. What is the ratio of the Gross enrolment ratio (%) in Primary schools in Suriname to that in Thailand?
Make the answer very short. 0.93. What is the ratio of the Gross enrolment ratio (%) in Secondary schools in Suriname to that in Thailand?
Provide a succinct answer. 1.67. What is the ratio of the Gross enrolment ratio (%) in Tertiary schools in Suriname to that in Thailand?
Make the answer very short. 0. What is the ratio of the Gross enrolment ratio (%) in Pre-primary schools in Suriname to that in Togo?
Your answer should be compact. 27.07. What is the ratio of the Gross enrolment ratio (%) in Primary schools in Suriname to that in Togo?
Ensure brevity in your answer.  0.98. What is the ratio of the Gross enrolment ratio (%) in Secondary schools in Suriname to that in Togo?
Your response must be concise. 6.32. What is the ratio of the Gross enrolment ratio (%) of Tertiary schools in Suriname to that in Togo?
Offer a very short reply. 0. What is the ratio of the Gross enrolment ratio (%) in Pre-primary schools in Swaziland to that in Syrian Arab Republic?
Provide a succinct answer. 0.78. What is the ratio of the Gross enrolment ratio (%) of Primary schools in Swaziland to that in Syrian Arab Republic?
Provide a short and direct response. 0.77. What is the ratio of the Gross enrolment ratio (%) in Secondary schools in Swaziland to that in Syrian Arab Republic?
Ensure brevity in your answer.  1.1. What is the ratio of the Gross enrolment ratio (%) in Tertiary schools in Swaziland to that in Syrian Arab Republic?
Your answer should be very brief. 17.09. What is the ratio of the Gross enrolment ratio (%) in Pre-primary schools in Swaziland to that in Thailand?
Offer a terse response. 0.54. What is the ratio of the Gross enrolment ratio (%) in Primary schools in Swaziland to that in Thailand?
Provide a succinct answer. 0.83. What is the ratio of the Gross enrolment ratio (%) of Secondary schools in Swaziland to that in Thailand?
Offer a terse response. 0.98. What is the ratio of the Gross enrolment ratio (%) of Tertiary schools in Swaziland to that in Thailand?
Offer a terse response. 0.95. What is the ratio of the Gross enrolment ratio (%) in Pre-primary schools in Swaziland to that in Togo?
Keep it short and to the point. 1.11. What is the ratio of the Gross enrolment ratio (%) in Primary schools in Swaziland to that in Togo?
Offer a very short reply. 0.88. What is the ratio of the Gross enrolment ratio (%) in Secondary schools in Swaziland to that in Togo?
Offer a terse response. 3.7. What is the ratio of the Gross enrolment ratio (%) of Tertiary schools in Swaziland to that in Togo?
Offer a terse response. 2.09. What is the ratio of the Gross enrolment ratio (%) in Pre-primary schools in Syrian Arab Republic to that in Thailand?
Keep it short and to the point. 0.69. What is the ratio of the Gross enrolment ratio (%) of Primary schools in Syrian Arab Republic to that in Thailand?
Your answer should be compact. 1.08. What is the ratio of the Gross enrolment ratio (%) of Secondary schools in Syrian Arab Republic to that in Thailand?
Give a very brief answer. 0.89. What is the ratio of the Gross enrolment ratio (%) of Tertiary schools in Syrian Arab Republic to that in Thailand?
Provide a succinct answer. 0.06. What is the ratio of the Gross enrolment ratio (%) in Pre-primary schools in Syrian Arab Republic to that in Togo?
Ensure brevity in your answer.  1.43. What is the ratio of the Gross enrolment ratio (%) in Primary schools in Syrian Arab Republic to that in Togo?
Ensure brevity in your answer.  1.14. What is the ratio of the Gross enrolment ratio (%) in Secondary schools in Syrian Arab Republic to that in Togo?
Your response must be concise. 3.35. What is the ratio of the Gross enrolment ratio (%) in Tertiary schools in Syrian Arab Republic to that in Togo?
Your response must be concise. 0.12. What is the ratio of the Gross enrolment ratio (%) in Pre-primary schools in Thailand to that in Togo?
Offer a very short reply. 2.06. What is the ratio of the Gross enrolment ratio (%) of Primary schools in Thailand to that in Togo?
Make the answer very short. 1.05. What is the ratio of the Gross enrolment ratio (%) of Secondary schools in Thailand to that in Togo?
Provide a succinct answer. 3.79. What is the ratio of the Gross enrolment ratio (%) in Tertiary schools in Thailand to that in Togo?
Offer a very short reply. 2.2. What is the difference between the highest and the second highest Gross enrolment ratio (%) in Pre-primary schools?
Offer a very short reply. 22.51. What is the difference between the highest and the second highest Gross enrolment ratio (%) of Primary schools?
Give a very brief answer. 8.23. What is the difference between the highest and the second highest Gross enrolment ratio (%) in Secondary schools?
Make the answer very short. 30.94. What is the difference between the highest and the second highest Gross enrolment ratio (%) in Tertiary schools?
Keep it short and to the point. 0.9. What is the difference between the highest and the lowest Gross enrolment ratio (%) of Pre-primary schools?
Ensure brevity in your answer.  69.35. What is the difference between the highest and the lowest Gross enrolment ratio (%) of Primary schools?
Make the answer very short. 52.88. What is the difference between the highest and the lowest Gross enrolment ratio (%) in Secondary schools?
Offer a very short reply. 78.71. What is the difference between the highest and the lowest Gross enrolment ratio (%) in Tertiary schools?
Make the answer very short. 17.98. 